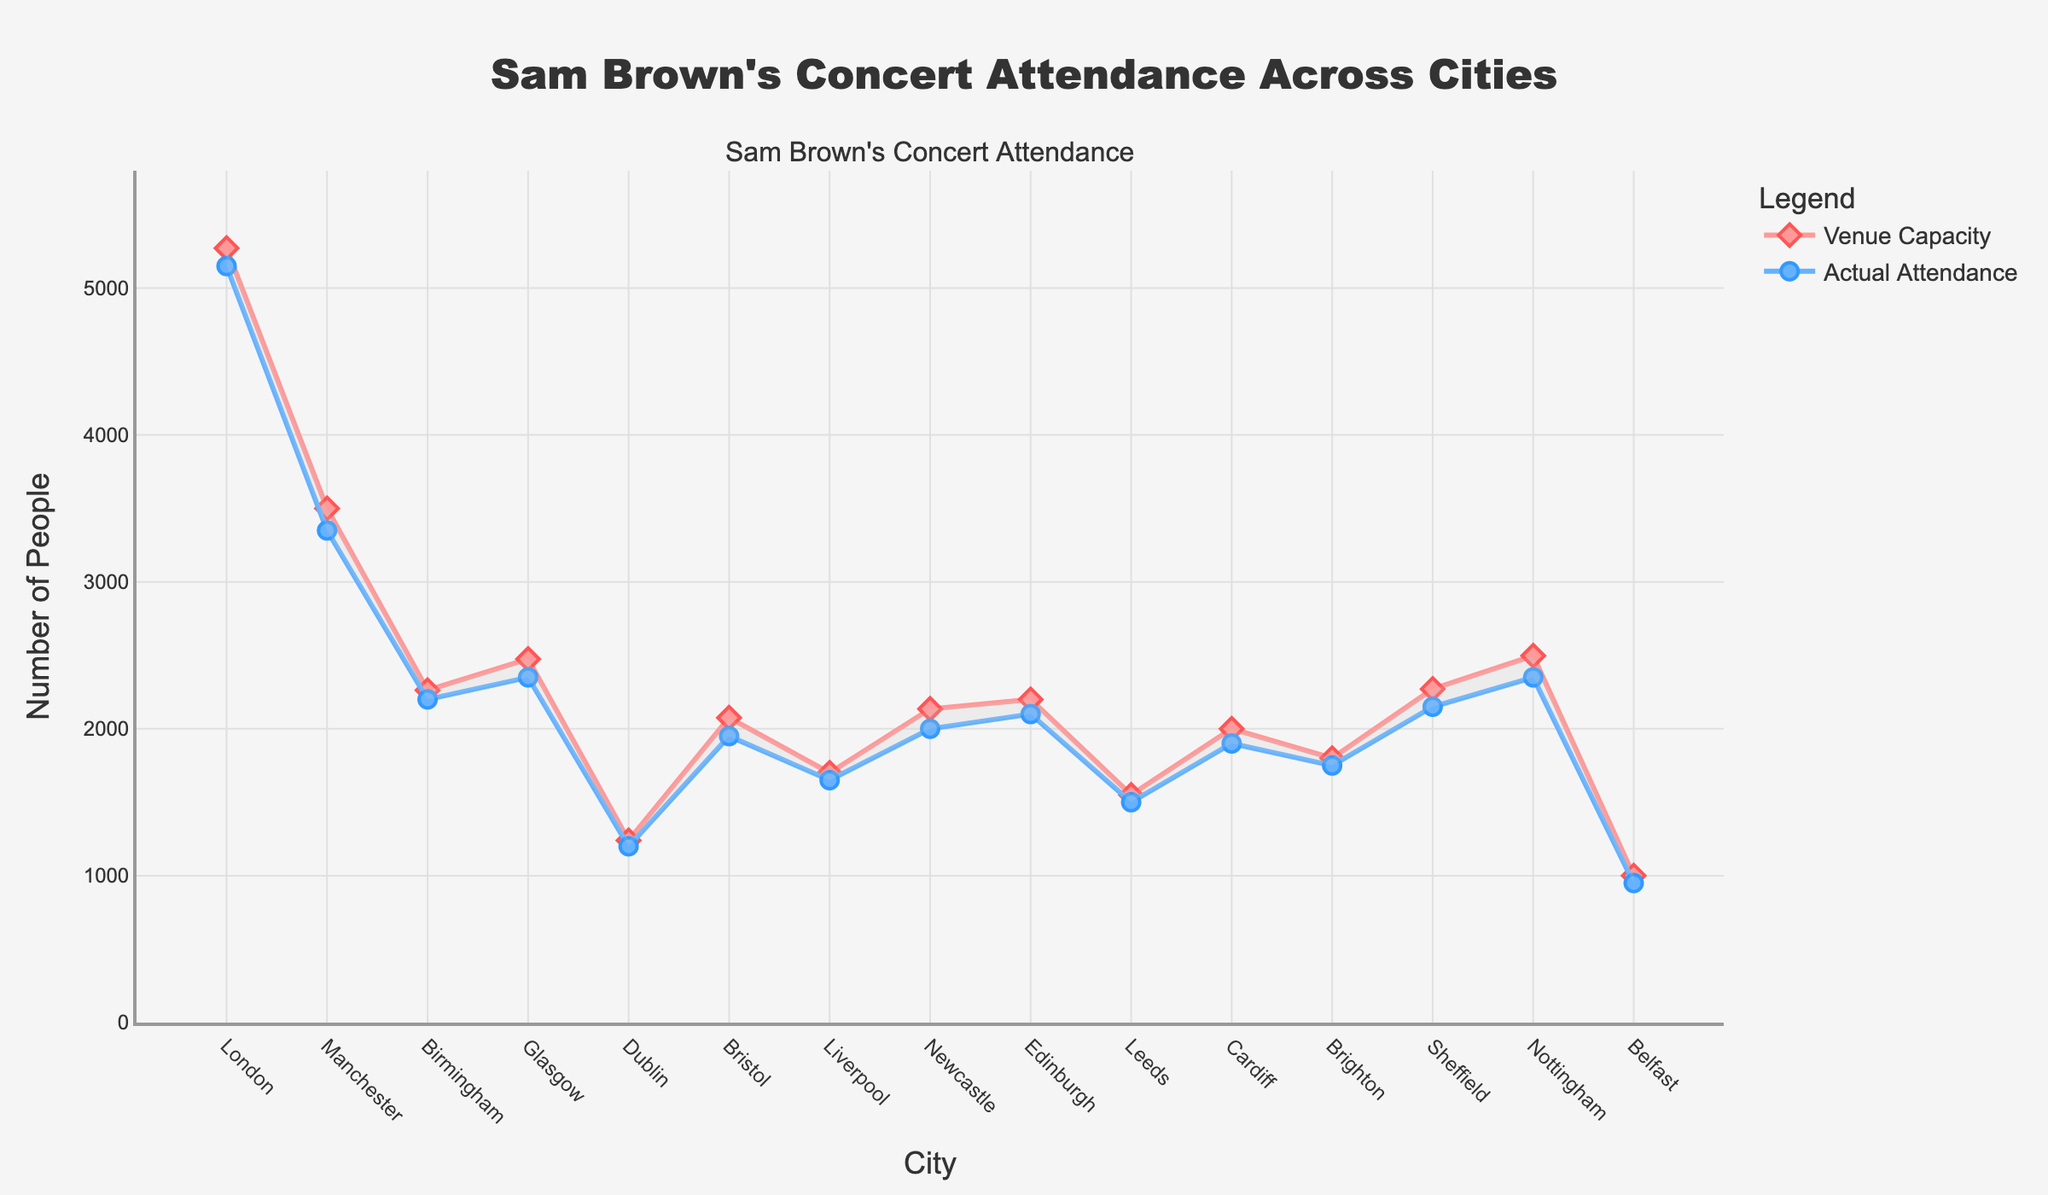Which city had the highest actual attendance? The line for actual attendance (blue circle markers) reaches its highest point at the city labeled "London" on the x-axis.
Answer: London Which venue had the lowest capacity? The line for venue capacity (red diamond markers) reaches its lowest point for the city labeled "Belfast" on the x-axis.
Answer: Ulster Hall in Belfast Is the attendance for most cities greater than 2000? Most of the cities have actual attendance points (blue circle markers) below the 2000 mark on the y-axis. Only a few cities like London, Manchester, and Birmingham have attendance above 2000.
Answer: No What is the difference in attendance between the city with the highest and the lowest attendance? The highest attendance is in London with 5150 people, while the lowest is in Belfast with 950 people. The difference is 5150 - 950 = 4200.
Answer: 4200 Which city had the smallest difference between capacity and attendance? By looking at the shaded area between the grey fill, the city where the grey area is thinnest is Dublin, indicating the smallest difference between the capacity and attendance.
Answer: Dublin What's the average attendance across all cities? Add all attendance figures: 5150 + 3350 + 2200 + 2350 + 1200 + 1950 + 1650 + 2000 + 2100 + 1500 + 1900 + 1750 + 2150 + 2350 + 950 = 36050. Total number of cities is 15. Thus, the average attendance is 36050 / 15 = 2403.33.
Answer: 2403.33 Which city had the highest percentage of capacity filled by attendance? The percentage of capacity filled is calculated for each city. For London: (5150/5272) ≈ 0.977, Manchester: (3350/3500) ≈ 0.957, Birmingham: (2200/2262) ≈ 0.973, and so on. The city with the highest percentage is London with approximately 0.977 or 97.7%.
Answer: London What can you infer about the popularity of Sam Brown's concerts in bigger venues? Bigger venues like the Royal Albert Hall in London and O2 Apollo in Manchester show strong attendance (lower gaps between capacity and attendance), suggesting high popularity and demand for Sam Brown's concerts in larger venues.
Answer: High popularity What's the total capacity across all venues? Add all capacity figures: 5272 + 3500 + 2262 + 2475 + 1240 + 2075 + 1700 + 2135 + 2200 + 1550 + 2000 + 1800 + 2271 + 2497 + 1000 = 38977. Total capacity is 38977.
Answer: 38977 